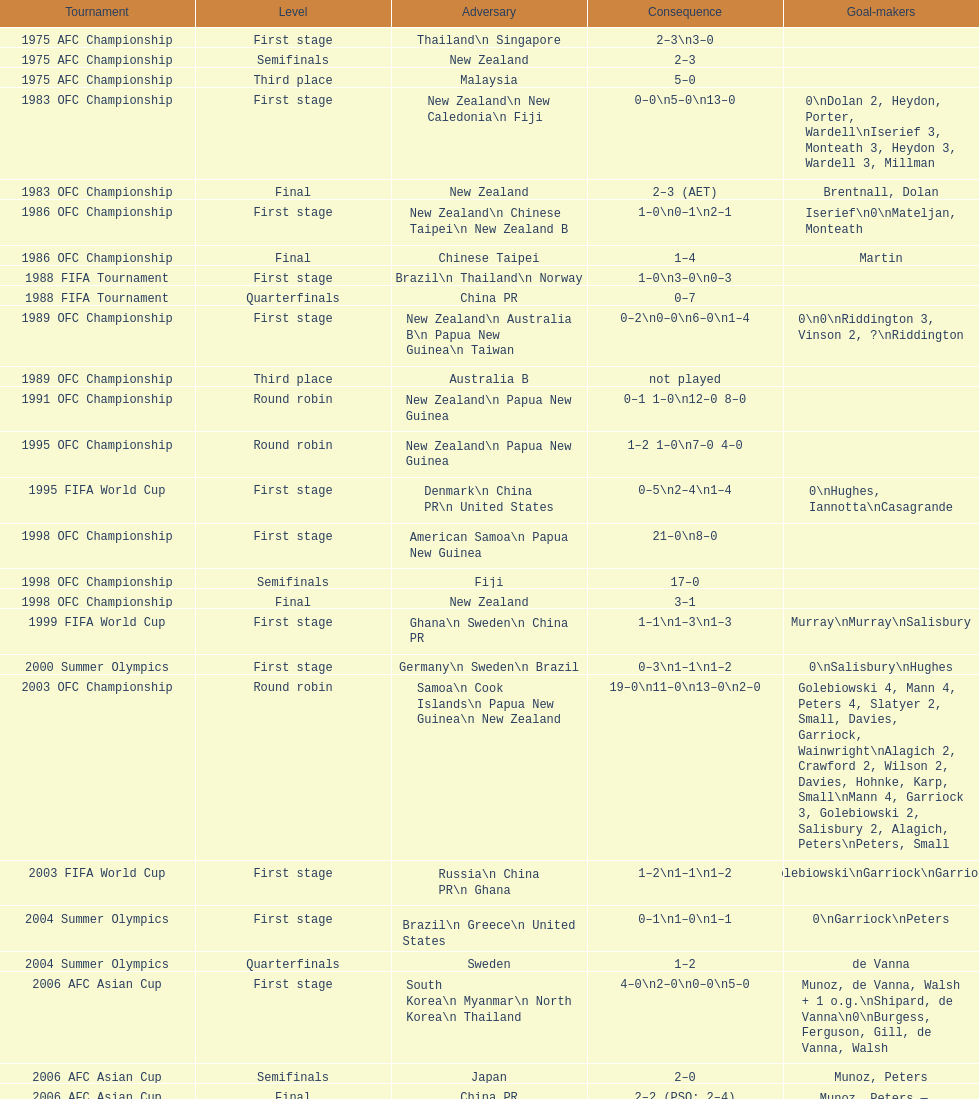How many points were scored in the final round of the 2012 summer olympics afc qualification? 12. 